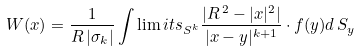Convert formula to latex. <formula><loc_0><loc_0><loc_500><loc_500>W ( x ) = \frac { 1 } { R \, | \sigma _ { k } | } \int \lim i t s _ { S ^ { k } } \frac { | R \, ^ { 2 } - | x | ^ { 2 } | } { | x - y | ^ { k + 1 } } \cdot f ( y ) d \, S _ { y }</formula> 